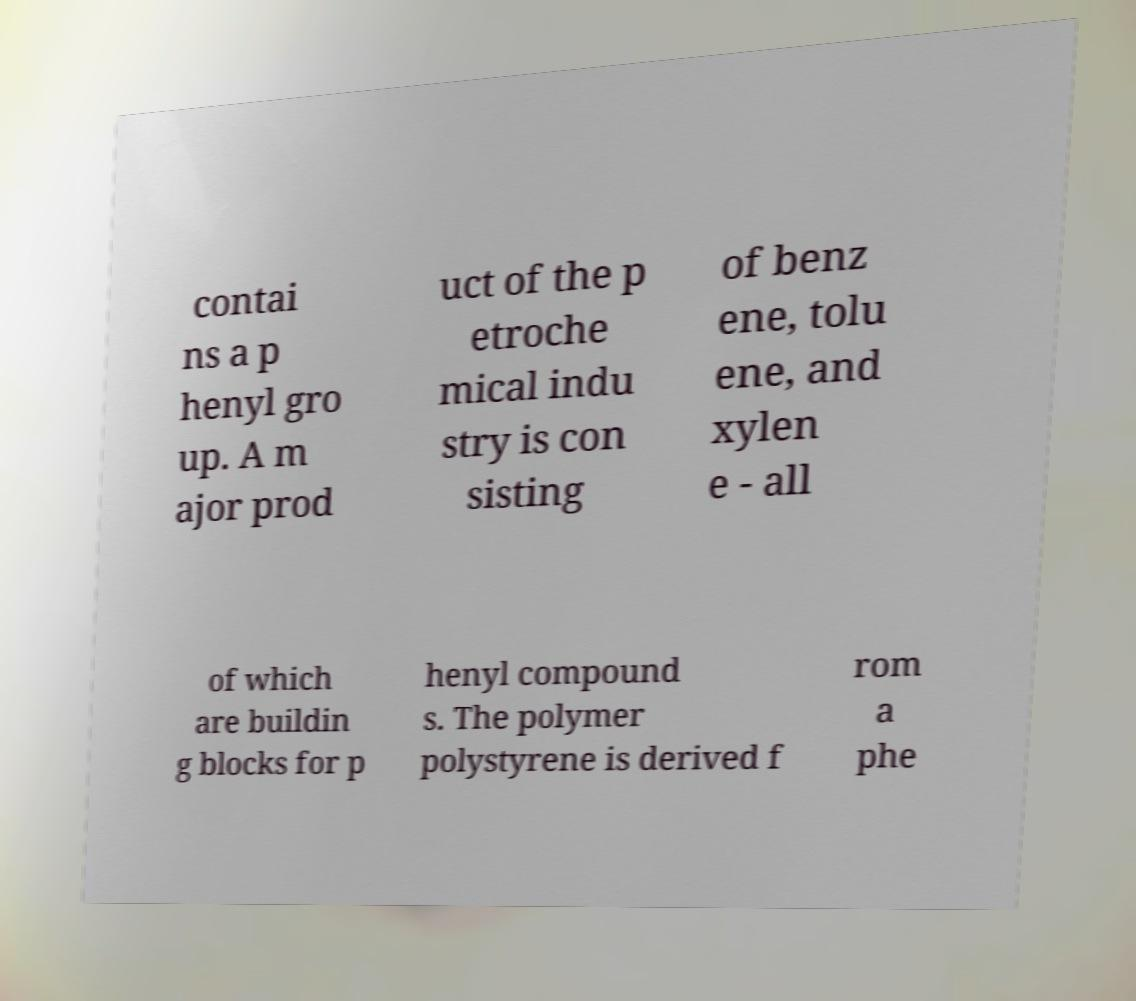Please identify and transcribe the text found in this image. contai ns a p henyl gro up. A m ajor prod uct of the p etroche mical indu stry is con sisting of benz ene, tolu ene, and xylen e - all of which are buildin g blocks for p henyl compound s. The polymer polystyrene is derived f rom a phe 